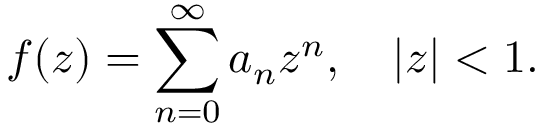<formula> <loc_0><loc_0><loc_500><loc_500>f ( z ) = \sum _ { n = 0 } ^ { \infty } a _ { n } z ^ { n } , \quad | z | < 1 .</formula> 